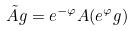<formula> <loc_0><loc_0><loc_500><loc_500>\tilde { A } g = e ^ { - \varphi } A ( e ^ { \varphi } g )</formula> 